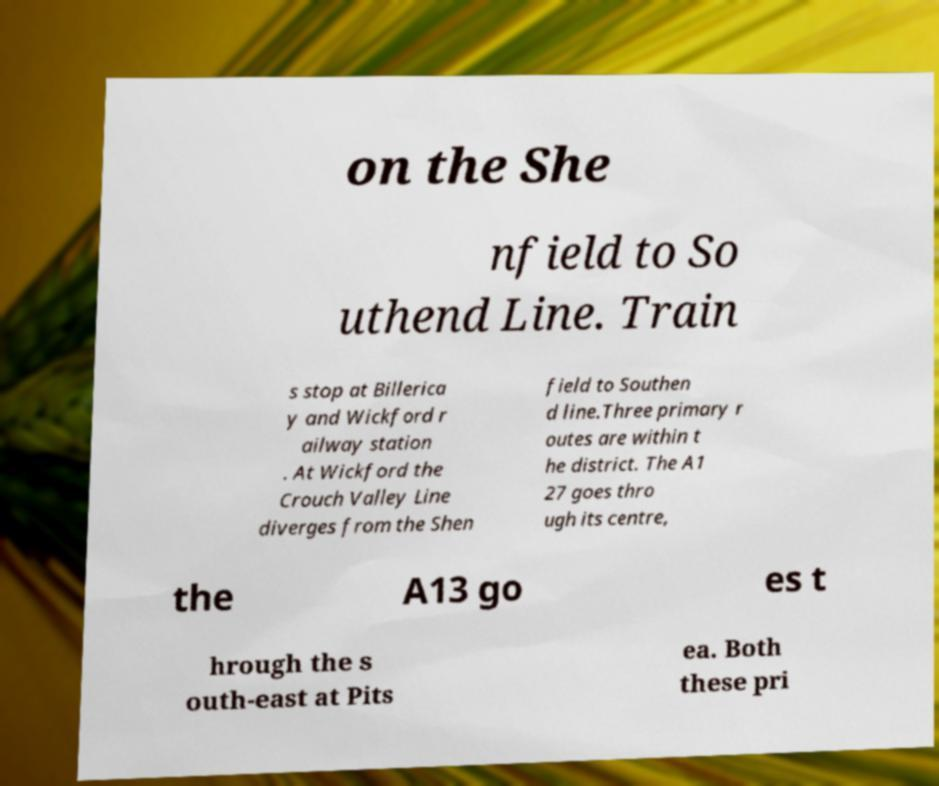There's text embedded in this image that I need extracted. Can you transcribe it verbatim? on the She nfield to So uthend Line. Train s stop at Billerica y and Wickford r ailway station . At Wickford the Crouch Valley Line diverges from the Shen field to Southen d line.Three primary r outes are within t he district. The A1 27 goes thro ugh its centre, the A13 go es t hrough the s outh-east at Pits ea. Both these pri 